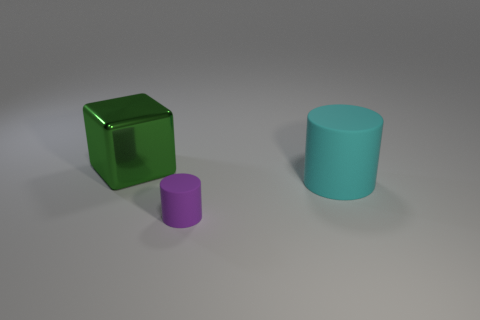Is there anything else that has the same size as the purple thing?
Provide a succinct answer. No. What color is the big thing in front of the large object that is to the left of the large cyan rubber thing?
Provide a short and direct response. Cyan. What number of objects are tiny purple rubber objects or objects in front of the big shiny thing?
Your response must be concise. 2. Are there any large matte cylinders of the same color as the big metal thing?
Your response must be concise. No. What number of brown objects are either metal things or small cylinders?
Your answer should be compact. 0. What number of other things are the same size as the purple thing?
Your answer should be compact. 0. How many big things are cyan cylinders or cylinders?
Offer a very short reply. 1. There is a green metallic cube; is it the same size as the matte cylinder that is behind the purple matte thing?
Make the answer very short. Yes. What number of other things are there of the same shape as the large metal object?
Make the answer very short. 0. What shape is the other cyan object that is the same material as the small object?
Your answer should be very brief. Cylinder. 